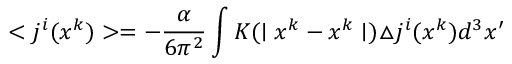Convert formula to latex. <formula><loc_0><loc_0><loc_500><loc_500>< j ^ { i } ( x ^ { k } ) > = - \frac { \alpha } { 6 \pi ^ { 2 } } \int K ( | x ^ { k } - x ^ { k } | ) \triangle j ^ { i } ( x ^ { k } ) d ^ { 3 } x ^ { \prime }</formula> 